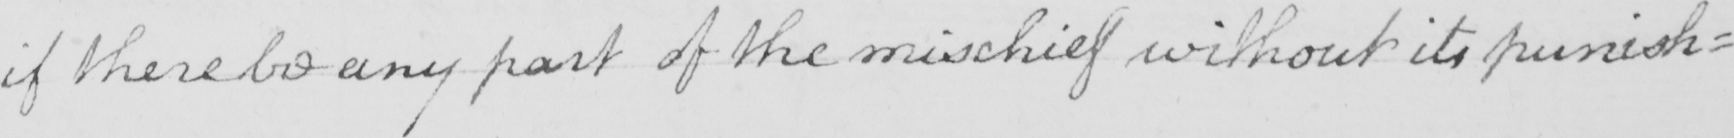What does this handwritten line say? if there be any part of the mischief without its punish= 